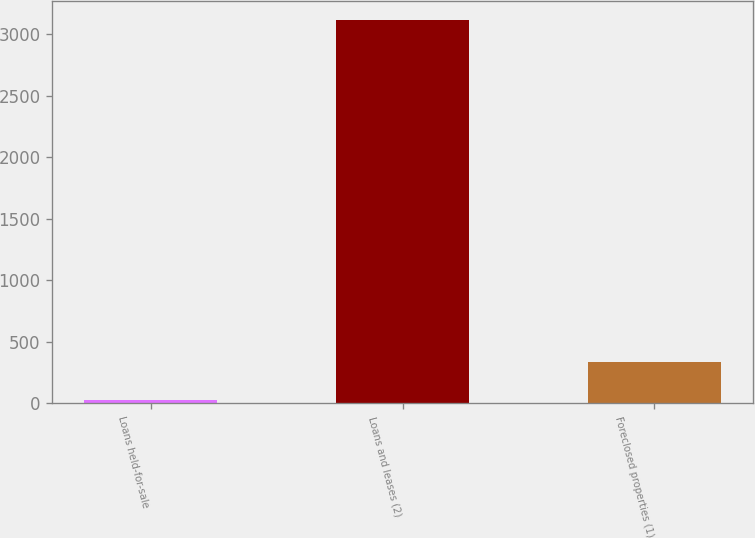Convert chart. <chart><loc_0><loc_0><loc_500><loc_500><bar_chart><fcel>Loans held-for-sale<fcel>Loans and leases (2)<fcel>Foreclosed properties (1)<nl><fcel>24<fcel>3116<fcel>333.2<nl></chart> 